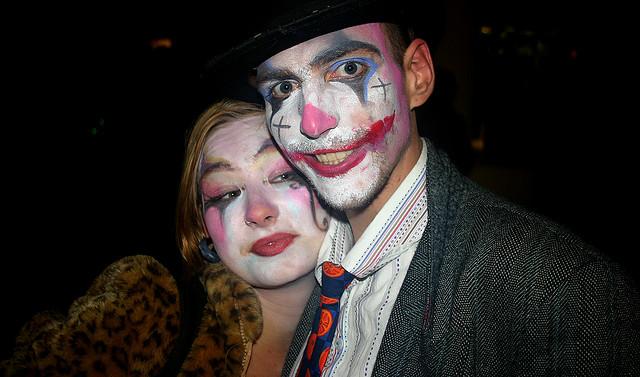What shape is painted on the man's cheeks?
Keep it brief. X. What is on the lady's lips?
Concise answer only. Lipstick. Might these people be circus clowns?
Keep it brief. Yes. Are the woman's eyes open?
Keep it brief. Yes. What is the black mark above the man's lip?
Short answer required. Mustache. What fruit is on the man's tie?
Be succinct. Orange. What holiday does this woman likely represent?
Give a very brief answer. Halloween. 